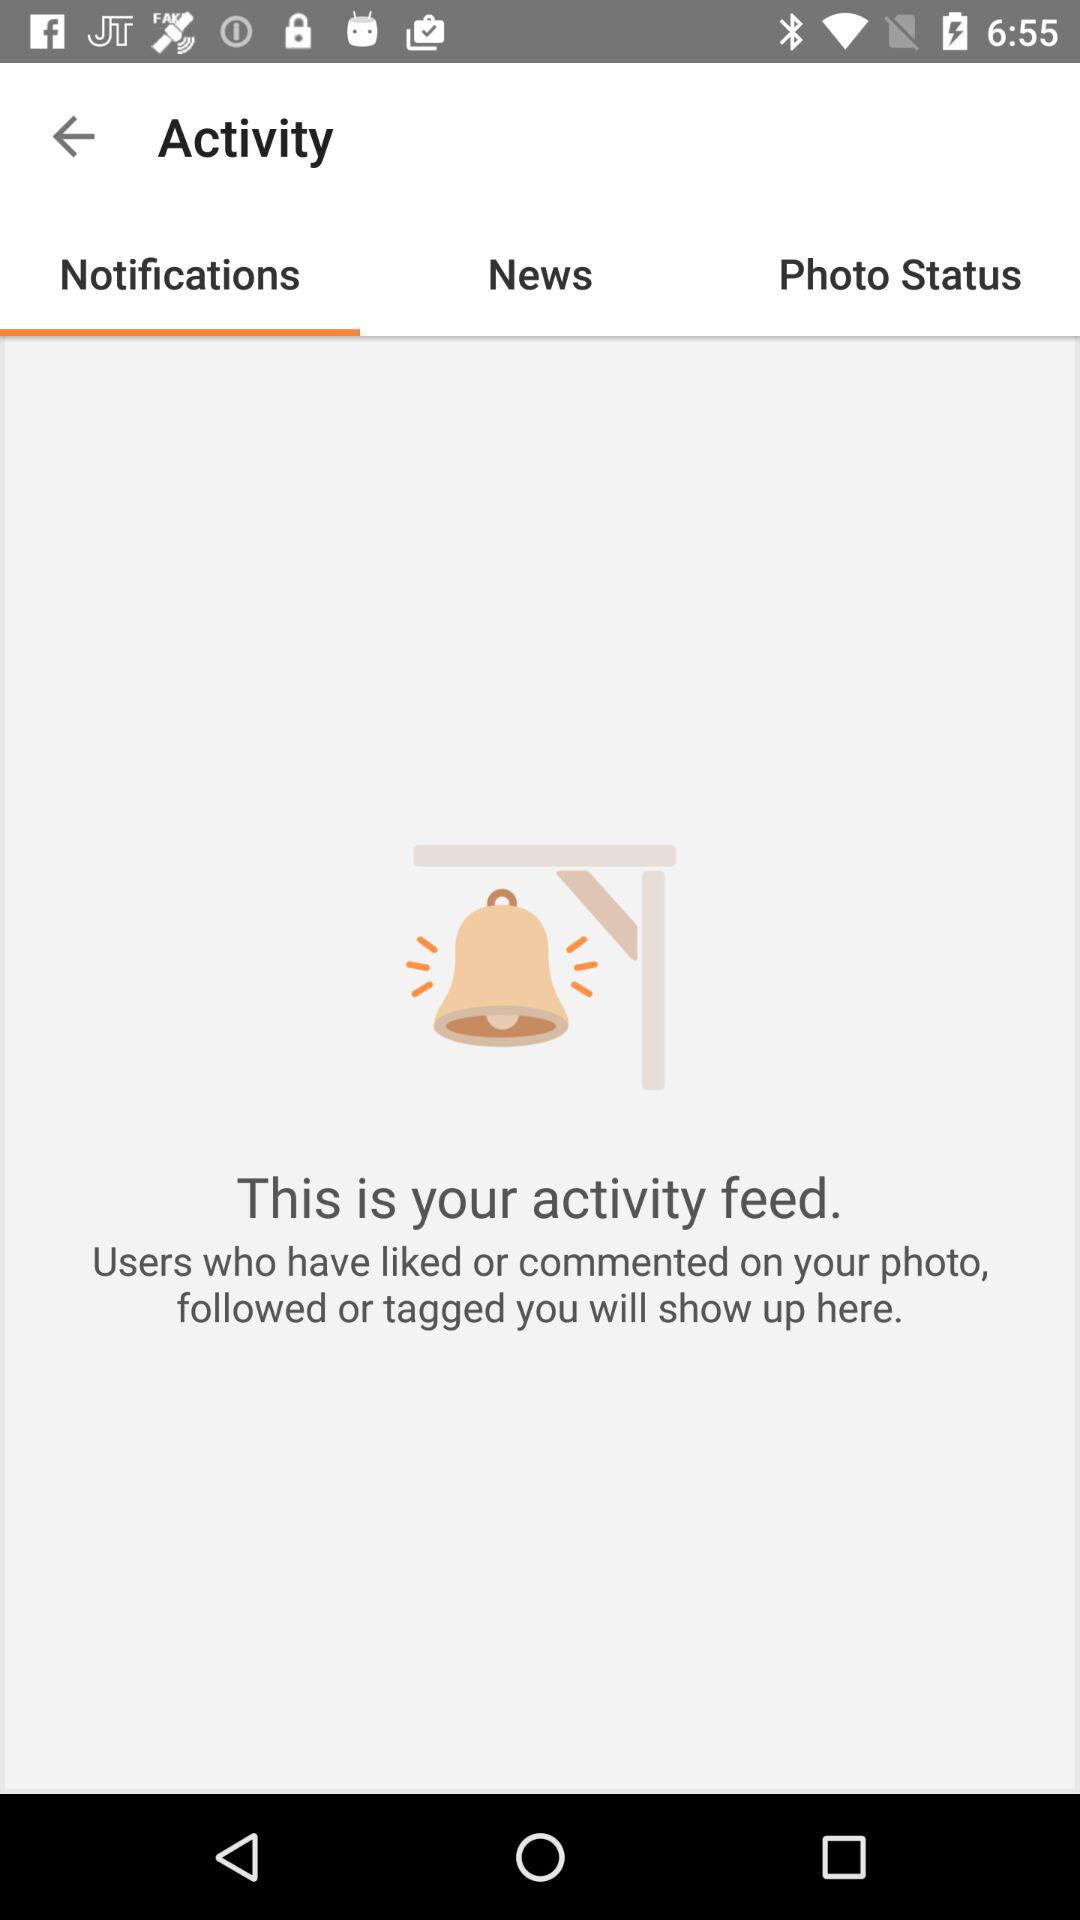What's the selected tab? The selected tab is "Notifications". 